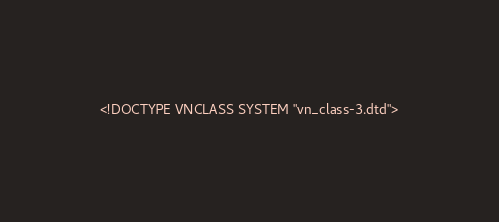Convert code to text. <code><loc_0><loc_0><loc_500><loc_500><_XML_><!DOCTYPE VNCLASS SYSTEM "vn_class-3.dtd"></code> 